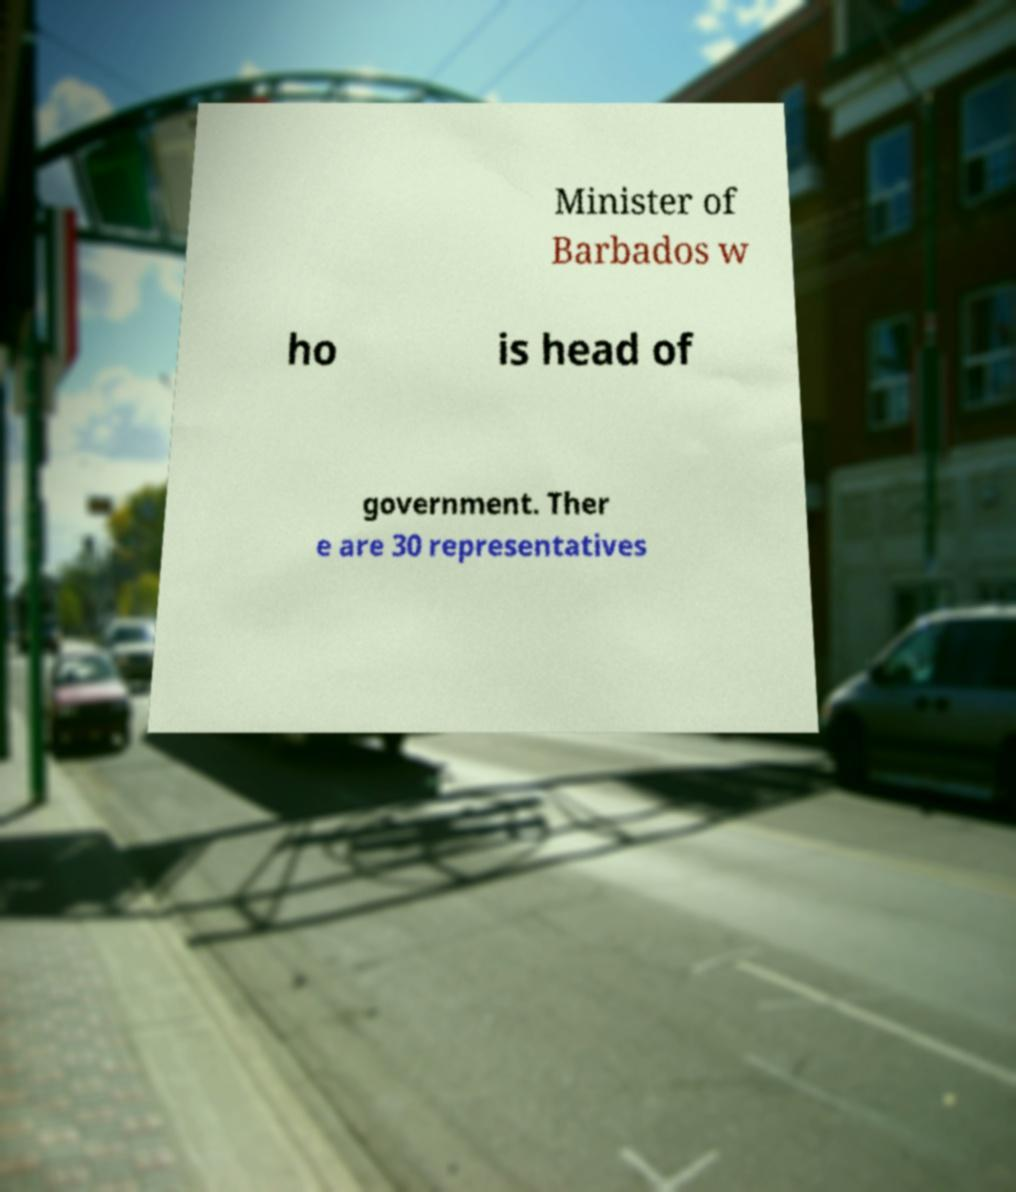Can you accurately transcribe the text from the provided image for me? Minister of Barbados w ho is head of government. Ther e are 30 representatives 